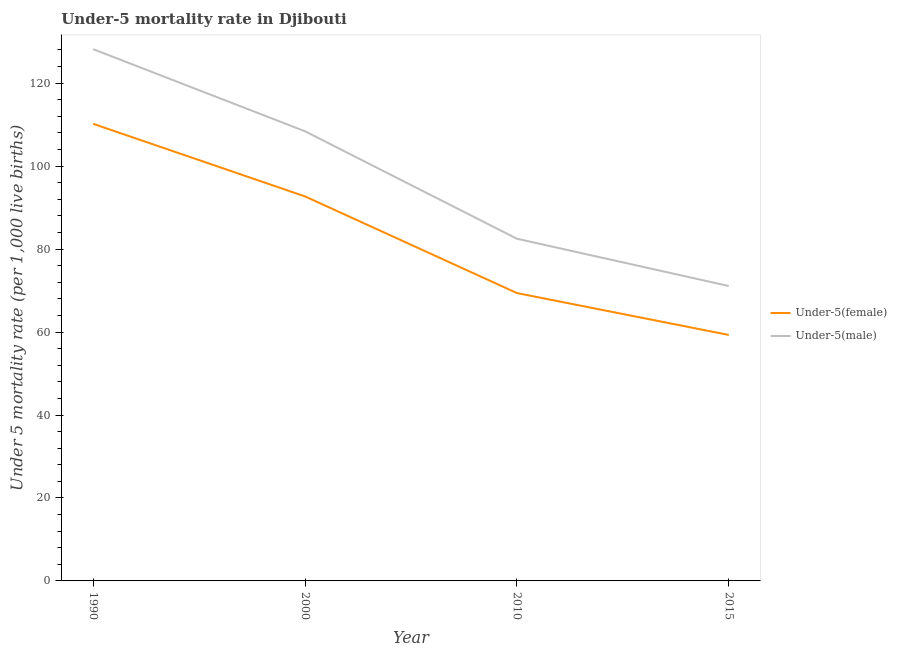How many different coloured lines are there?
Your response must be concise. 2. Does the line corresponding to under-5 female mortality rate intersect with the line corresponding to under-5 male mortality rate?
Offer a very short reply. No. Is the number of lines equal to the number of legend labels?
Your response must be concise. Yes. What is the under-5 male mortality rate in 2000?
Offer a very short reply. 108.4. Across all years, what is the maximum under-5 female mortality rate?
Provide a short and direct response. 110.2. Across all years, what is the minimum under-5 male mortality rate?
Make the answer very short. 71.1. In which year was the under-5 female mortality rate minimum?
Make the answer very short. 2015. What is the total under-5 female mortality rate in the graph?
Keep it short and to the point. 331.6. What is the difference between the under-5 female mortality rate in 2000 and that in 2010?
Give a very brief answer. 23.3. What is the difference between the under-5 female mortality rate in 2015 and the under-5 male mortality rate in 1990?
Offer a very short reply. -68.9. What is the average under-5 male mortality rate per year?
Give a very brief answer. 97.55. In the year 1990, what is the difference between the under-5 female mortality rate and under-5 male mortality rate?
Your response must be concise. -18. In how many years, is the under-5 female mortality rate greater than 52?
Make the answer very short. 4. What is the ratio of the under-5 female mortality rate in 2000 to that in 2015?
Your response must be concise. 1.56. Is the under-5 male mortality rate in 2000 less than that in 2010?
Offer a terse response. No. What is the difference between the highest and the second highest under-5 female mortality rate?
Your response must be concise. 17.5. What is the difference between the highest and the lowest under-5 female mortality rate?
Your response must be concise. 50.9. Is the sum of the under-5 male mortality rate in 1990 and 2000 greater than the maximum under-5 female mortality rate across all years?
Your answer should be very brief. Yes. Does the under-5 female mortality rate monotonically increase over the years?
Give a very brief answer. No. Is the under-5 male mortality rate strictly greater than the under-5 female mortality rate over the years?
Provide a short and direct response. Yes. Is the under-5 male mortality rate strictly less than the under-5 female mortality rate over the years?
Your answer should be very brief. No. What is the difference between two consecutive major ticks on the Y-axis?
Your response must be concise. 20. Where does the legend appear in the graph?
Make the answer very short. Center right. How are the legend labels stacked?
Offer a terse response. Vertical. What is the title of the graph?
Ensure brevity in your answer.  Under-5 mortality rate in Djibouti. Does "Number of departures" appear as one of the legend labels in the graph?
Give a very brief answer. No. What is the label or title of the Y-axis?
Offer a very short reply. Under 5 mortality rate (per 1,0 live births). What is the Under 5 mortality rate (per 1,000 live births) in Under-5(female) in 1990?
Offer a very short reply. 110.2. What is the Under 5 mortality rate (per 1,000 live births) in Under-5(male) in 1990?
Give a very brief answer. 128.2. What is the Under 5 mortality rate (per 1,000 live births) of Under-5(female) in 2000?
Give a very brief answer. 92.7. What is the Under 5 mortality rate (per 1,000 live births) of Under-5(male) in 2000?
Your answer should be compact. 108.4. What is the Under 5 mortality rate (per 1,000 live births) in Under-5(female) in 2010?
Make the answer very short. 69.4. What is the Under 5 mortality rate (per 1,000 live births) of Under-5(male) in 2010?
Make the answer very short. 82.5. What is the Under 5 mortality rate (per 1,000 live births) of Under-5(female) in 2015?
Provide a succinct answer. 59.3. What is the Under 5 mortality rate (per 1,000 live births) of Under-5(male) in 2015?
Keep it short and to the point. 71.1. Across all years, what is the maximum Under 5 mortality rate (per 1,000 live births) of Under-5(female)?
Offer a terse response. 110.2. Across all years, what is the maximum Under 5 mortality rate (per 1,000 live births) in Under-5(male)?
Offer a terse response. 128.2. Across all years, what is the minimum Under 5 mortality rate (per 1,000 live births) of Under-5(female)?
Your answer should be compact. 59.3. Across all years, what is the minimum Under 5 mortality rate (per 1,000 live births) of Under-5(male)?
Ensure brevity in your answer.  71.1. What is the total Under 5 mortality rate (per 1,000 live births) in Under-5(female) in the graph?
Ensure brevity in your answer.  331.6. What is the total Under 5 mortality rate (per 1,000 live births) of Under-5(male) in the graph?
Your answer should be compact. 390.2. What is the difference between the Under 5 mortality rate (per 1,000 live births) of Under-5(male) in 1990 and that in 2000?
Your response must be concise. 19.8. What is the difference between the Under 5 mortality rate (per 1,000 live births) of Under-5(female) in 1990 and that in 2010?
Ensure brevity in your answer.  40.8. What is the difference between the Under 5 mortality rate (per 1,000 live births) of Under-5(male) in 1990 and that in 2010?
Your answer should be compact. 45.7. What is the difference between the Under 5 mortality rate (per 1,000 live births) in Under-5(female) in 1990 and that in 2015?
Offer a very short reply. 50.9. What is the difference between the Under 5 mortality rate (per 1,000 live births) in Under-5(male) in 1990 and that in 2015?
Your answer should be compact. 57.1. What is the difference between the Under 5 mortality rate (per 1,000 live births) in Under-5(female) in 2000 and that in 2010?
Give a very brief answer. 23.3. What is the difference between the Under 5 mortality rate (per 1,000 live births) in Under-5(male) in 2000 and that in 2010?
Your answer should be very brief. 25.9. What is the difference between the Under 5 mortality rate (per 1,000 live births) in Under-5(female) in 2000 and that in 2015?
Your answer should be very brief. 33.4. What is the difference between the Under 5 mortality rate (per 1,000 live births) in Under-5(male) in 2000 and that in 2015?
Ensure brevity in your answer.  37.3. What is the difference between the Under 5 mortality rate (per 1,000 live births) of Under-5(female) in 2010 and that in 2015?
Make the answer very short. 10.1. What is the difference between the Under 5 mortality rate (per 1,000 live births) of Under-5(male) in 2010 and that in 2015?
Provide a succinct answer. 11.4. What is the difference between the Under 5 mortality rate (per 1,000 live births) in Under-5(female) in 1990 and the Under 5 mortality rate (per 1,000 live births) in Under-5(male) in 2000?
Ensure brevity in your answer.  1.8. What is the difference between the Under 5 mortality rate (per 1,000 live births) of Under-5(female) in 1990 and the Under 5 mortality rate (per 1,000 live births) of Under-5(male) in 2010?
Your answer should be very brief. 27.7. What is the difference between the Under 5 mortality rate (per 1,000 live births) of Under-5(female) in 1990 and the Under 5 mortality rate (per 1,000 live births) of Under-5(male) in 2015?
Your answer should be compact. 39.1. What is the difference between the Under 5 mortality rate (per 1,000 live births) of Under-5(female) in 2000 and the Under 5 mortality rate (per 1,000 live births) of Under-5(male) in 2015?
Offer a very short reply. 21.6. What is the average Under 5 mortality rate (per 1,000 live births) in Under-5(female) per year?
Ensure brevity in your answer.  82.9. What is the average Under 5 mortality rate (per 1,000 live births) of Under-5(male) per year?
Your response must be concise. 97.55. In the year 1990, what is the difference between the Under 5 mortality rate (per 1,000 live births) in Under-5(female) and Under 5 mortality rate (per 1,000 live births) in Under-5(male)?
Offer a very short reply. -18. In the year 2000, what is the difference between the Under 5 mortality rate (per 1,000 live births) of Under-5(female) and Under 5 mortality rate (per 1,000 live births) of Under-5(male)?
Ensure brevity in your answer.  -15.7. What is the ratio of the Under 5 mortality rate (per 1,000 live births) of Under-5(female) in 1990 to that in 2000?
Give a very brief answer. 1.19. What is the ratio of the Under 5 mortality rate (per 1,000 live births) in Under-5(male) in 1990 to that in 2000?
Ensure brevity in your answer.  1.18. What is the ratio of the Under 5 mortality rate (per 1,000 live births) in Under-5(female) in 1990 to that in 2010?
Offer a very short reply. 1.59. What is the ratio of the Under 5 mortality rate (per 1,000 live births) in Under-5(male) in 1990 to that in 2010?
Keep it short and to the point. 1.55. What is the ratio of the Under 5 mortality rate (per 1,000 live births) in Under-5(female) in 1990 to that in 2015?
Your answer should be very brief. 1.86. What is the ratio of the Under 5 mortality rate (per 1,000 live births) of Under-5(male) in 1990 to that in 2015?
Provide a succinct answer. 1.8. What is the ratio of the Under 5 mortality rate (per 1,000 live births) of Under-5(female) in 2000 to that in 2010?
Keep it short and to the point. 1.34. What is the ratio of the Under 5 mortality rate (per 1,000 live births) in Under-5(male) in 2000 to that in 2010?
Provide a succinct answer. 1.31. What is the ratio of the Under 5 mortality rate (per 1,000 live births) of Under-5(female) in 2000 to that in 2015?
Ensure brevity in your answer.  1.56. What is the ratio of the Under 5 mortality rate (per 1,000 live births) of Under-5(male) in 2000 to that in 2015?
Your answer should be compact. 1.52. What is the ratio of the Under 5 mortality rate (per 1,000 live births) in Under-5(female) in 2010 to that in 2015?
Offer a very short reply. 1.17. What is the ratio of the Under 5 mortality rate (per 1,000 live births) in Under-5(male) in 2010 to that in 2015?
Offer a terse response. 1.16. What is the difference between the highest and the second highest Under 5 mortality rate (per 1,000 live births) of Under-5(male)?
Your response must be concise. 19.8. What is the difference between the highest and the lowest Under 5 mortality rate (per 1,000 live births) in Under-5(female)?
Your answer should be very brief. 50.9. What is the difference between the highest and the lowest Under 5 mortality rate (per 1,000 live births) in Under-5(male)?
Your answer should be very brief. 57.1. 